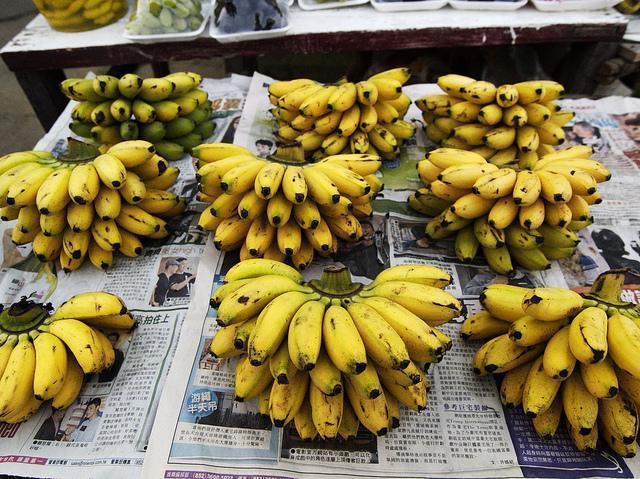How many bananas are visible?
Give a very brief answer. 8. How many dining tables are visible?
Give a very brief answer. 2. How many people are standing in front of the horse?
Give a very brief answer. 0. 